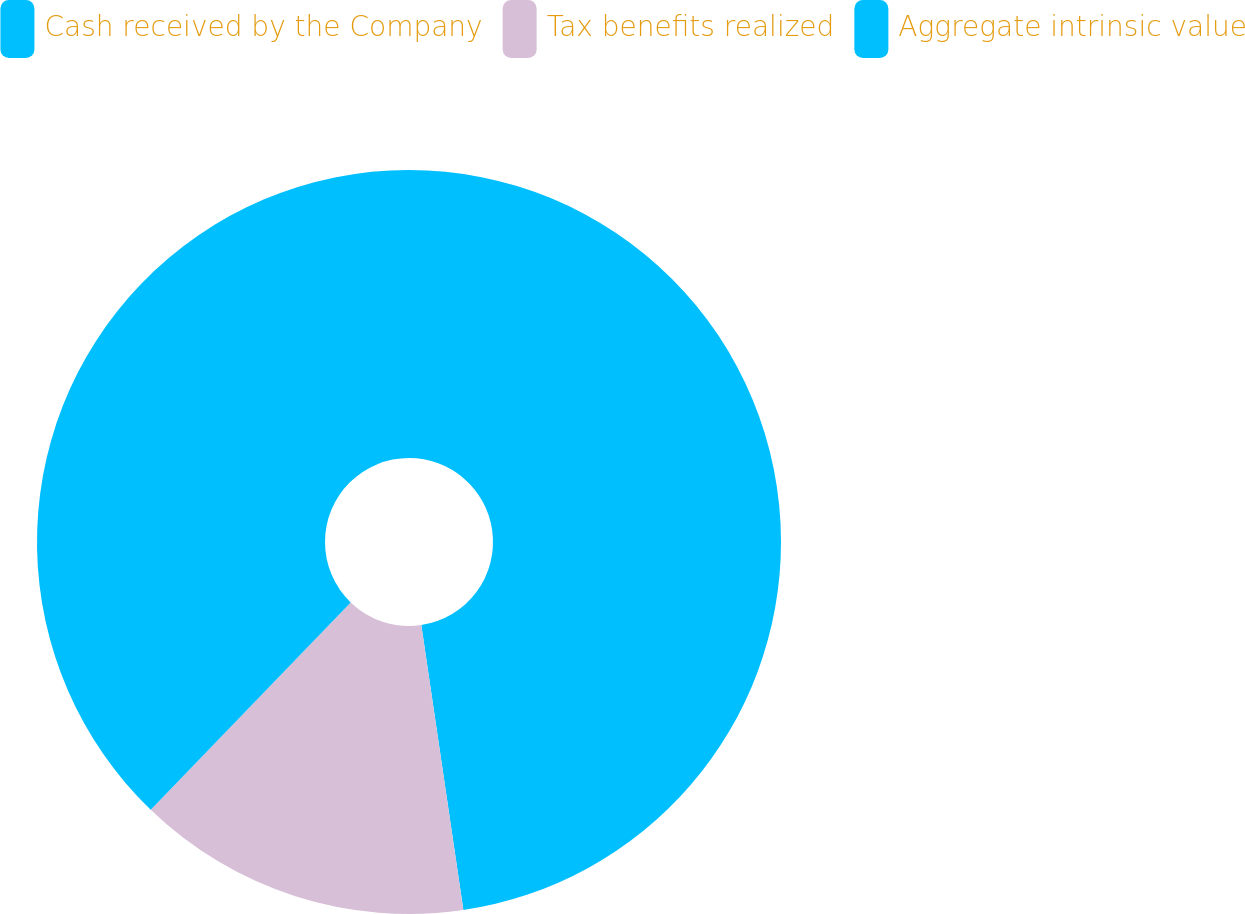Convert chart. <chart><loc_0><loc_0><loc_500><loc_500><pie_chart><fcel>Cash received by the Company<fcel>Tax benefits realized<fcel>Aggregate intrinsic value<nl><fcel>47.67%<fcel>14.55%<fcel>37.79%<nl></chart> 